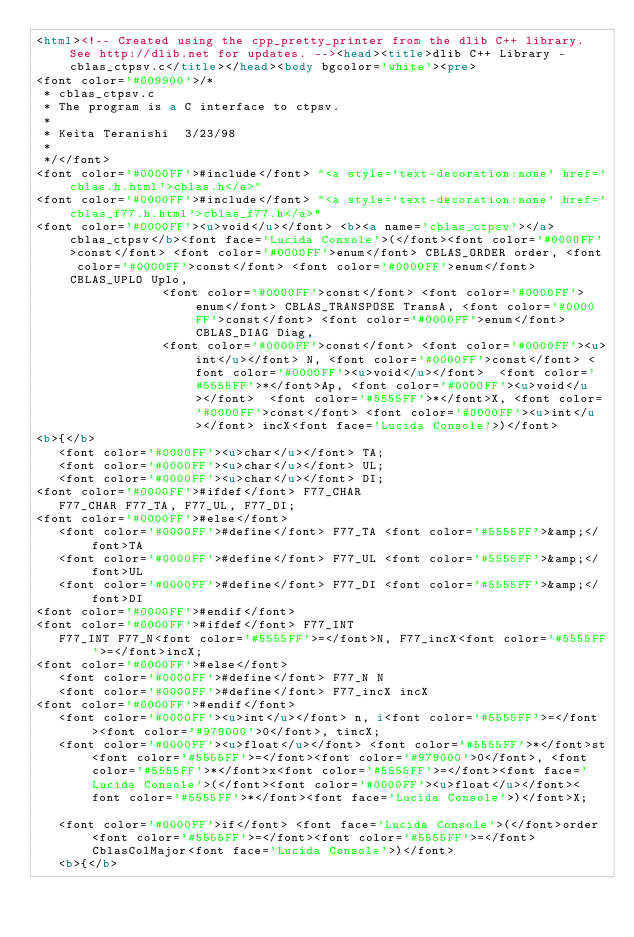Convert code to text. <code><loc_0><loc_0><loc_500><loc_500><_HTML_><html><!-- Created using the cpp_pretty_printer from the dlib C++ library.  See http://dlib.net for updates. --><head><title>dlib C++ Library - cblas_ctpsv.c</title></head><body bgcolor='white'><pre>
<font color='#009900'>/*
 * cblas_ctpsv.c
 * The program is a C interface to ctpsv.
 * 
 * Keita Teranishi  3/23/98
 *
 */</font>
<font color='#0000FF'>#include</font> "<a style='text-decoration:none' href='cblas.h.html'>cblas.h</a>"
<font color='#0000FF'>#include</font> "<a style='text-decoration:none' href='cblas_f77.h.html'>cblas_f77.h</a>"
<font color='#0000FF'><u>void</u></font> <b><a name='cblas_ctpsv'></a>cblas_ctpsv</b><font face='Lucida Console'>(</font><font color='#0000FF'>const</font> <font color='#0000FF'>enum</font> CBLAS_ORDER order, <font color='#0000FF'>const</font> <font color='#0000FF'>enum</font> CBLAS_UPLO Uplo,
                 <font color='#0000FF'>const</font> <font color='#0000FF'>enum</font> CBLAS_TRANSPOSE TransA, <font color='#0000FF'>const</font> <font color='#0000FF'>enum</font> CBLAS_DIAG Diag,
                 <font color='#0000FF'>const</font> <font color='#0000FF'><u>int</u></font> N, <font color='#0000FF'>const</font> <font color='#0000FF'><u>void</u></font>  <font color='#5555FF'>*</font>Ap, <font color='#0000FF'><u>void</u></font>  <font color='#5555FF'>*</font>X, <font color='#0000FF'>const</font> <font color='#0000FF'><u>int</u></font> incX<font face='Lucida Console'>)</font>
<b>{</b>
   <font color='#0000FF'><u>char</u></font> TA;
   <font color='#0000FF'><u>char</u></font> UL;
   <font color='#0000FF'><u>char</u></font> DI;
<font color='#0000FF'>#ifdef</font> F77_CHAR
   F77_CHAR F77_TA, F77_UL, F77_DI;
<font color='#0000FF'>#else</font>
   <font color='#0000FF'>#define</font> F77_TA <font color='#5555FF'>&amp;</font>TA
   <font color='#0000FF'>#define</font> F77_UL <font color='#5555FF'>&amp;</font>UL
   <font color='#0000FF'>#define</font> F77_DI <font color='#5555FF'>&amp;</font>DI   
<font color='#0000FF'>#endif</font>
<font color='#0000FF'>#ifdef</font> F77_INT
   F77_INT F77_N<font color='#5555FF'>=</font>N, F77_incX<font color='#5555FF'>=</font>incX;
<font color='#0000FF'>#else</font>
   <font color='#0000FF'>#define</font> F77_N N
   <font color='#0000FF'>#define</font> F77_incX incX
<font color='#0000FF'>#endif</font>
   <font color='#0000FF'><u>int</u></font> n, i<font color='#5555FF'>=</font><font color='#979000'>0</font>, tincX; 
   <font color='#0000FF'><u>float</u></font> <font color='#5555FF'>*</font>st<font color='#5555FF'>=</font><font color='#979000'>0</font>, <font color='#5555FF'>*</font>x<font color='#5555FF'>=</font><font face='Lucida Console'>(</font><font color='#0000FF'><u>float</u></font><font color='#5555FF'>*</font><font face='Lucida Console'>)</font>X;

   <font color='#0000FF'>if</font> <font face='Lucida Console'>(</font>order <font color='#5555FF'>=</font><font color='#5555FF'>=</font> CblasColMajor<font face='Lucida Console'>)</font>
   <b>{</b></code> 